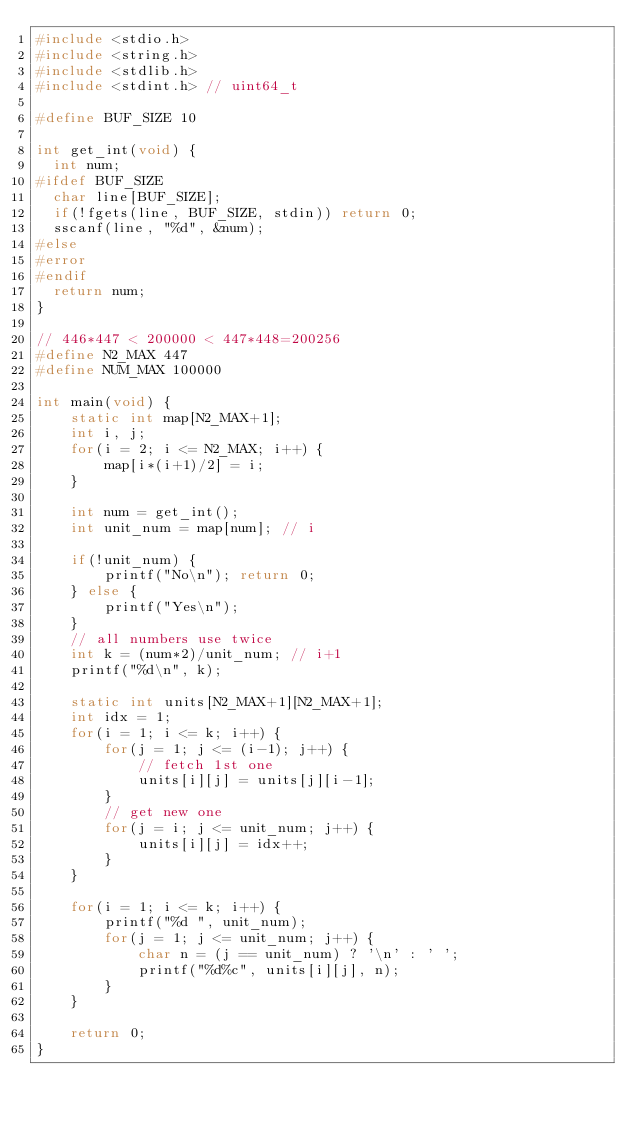<code> <loc_0><loc_0><loc_500><loc_500><_C_>#include <stdio.h>
#include <string.h>
#include <stdlib.h>
#include <stdint.h> // uint64_t

#define BUF_SIZE 10

int get_int(void) {
  int num;
#ifdef BUF_SIZE
  char line[BUF_SIZE];
  if(!fgets(line, BUF_SIZE, stdin)) return 0;
  sscanf(line, "%d", &num);
#else
#error
#endif
  return num;
}

// 446*447 < 200000 < 447*448=200256
#define N2_MAX 447
#define NUM_MAX 100000

int main(void) {
    static int map[N2_MAX+1];
    int i, j;
    for(i = 2; i <= N2_MAX; i++) {
        map[i*(i+1)/2] = i;
    }

    int num = get_int();
    int unit_num = map[num]; // i

    if(!unit_num) {
        printf("No\n"); return 0;
    } else {
        printf("Yes\n");
    }
    // all numbers use twice
    int k = (num*2)/unit_num; // i+1
    printf("%d\n", k);

    static int units[N2_MAX+1][N2_MAX+1];
    int idx = 1;
    for(i = 1; i <= k; i++) {
        for(j = 1; j <= (i-1); j++) {
            // fetch 1st one
            units[i][j] = units[j][i-1];
        }
        // get new one
        for(j = i; j <= unit_num; j++) {
            units[i][j] = idx++;
        }
    }

    for(i = 1; i <= k; i++) {
        printf("%d ", unit_num);
        for(j = 1; j <= unit_num; j++) {
            char n = (j == unit_num) ? '\n' : ' ';
            printf("%d%c", units[i][j], n);
        }
    }

    return 0;
}</code> 